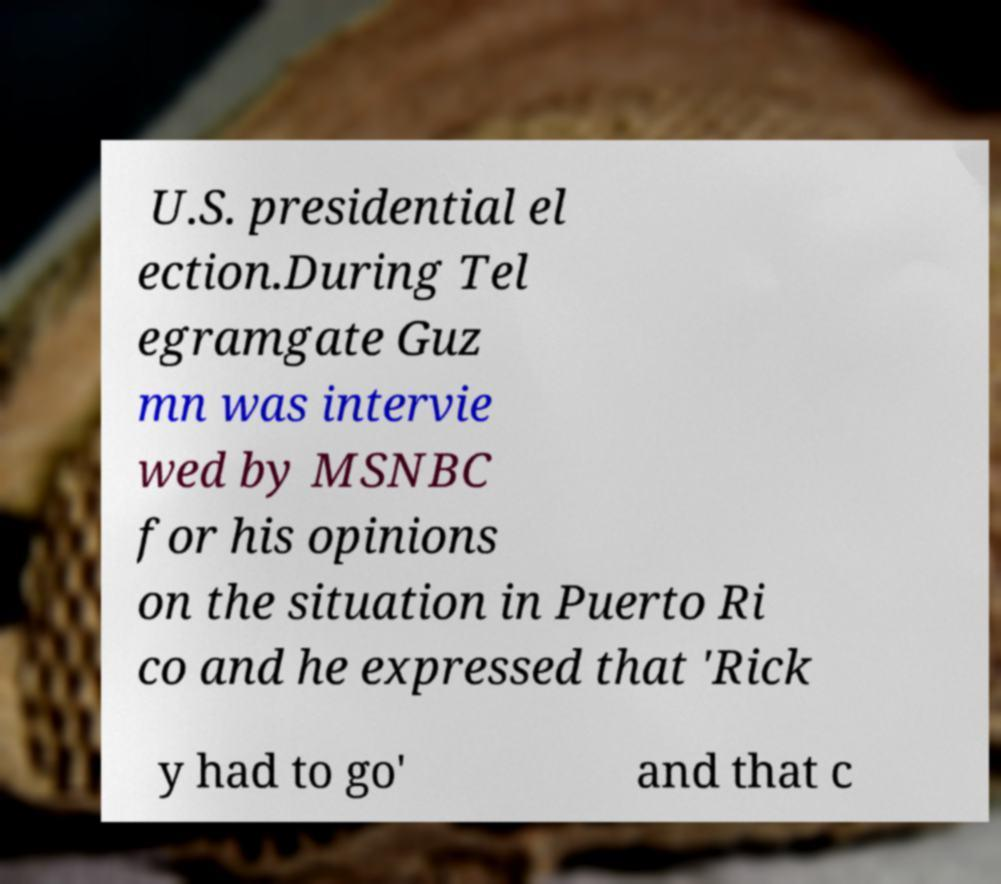Could you assist in decoding the text presented in this image and type it out clearly? U.S. presidential el ection.During Tel egramgate Guz mn was intervie wed by MSNBC for his opinions on the situation in Puerto Ri co and he expressed that 'Rick y had to go' and that c 